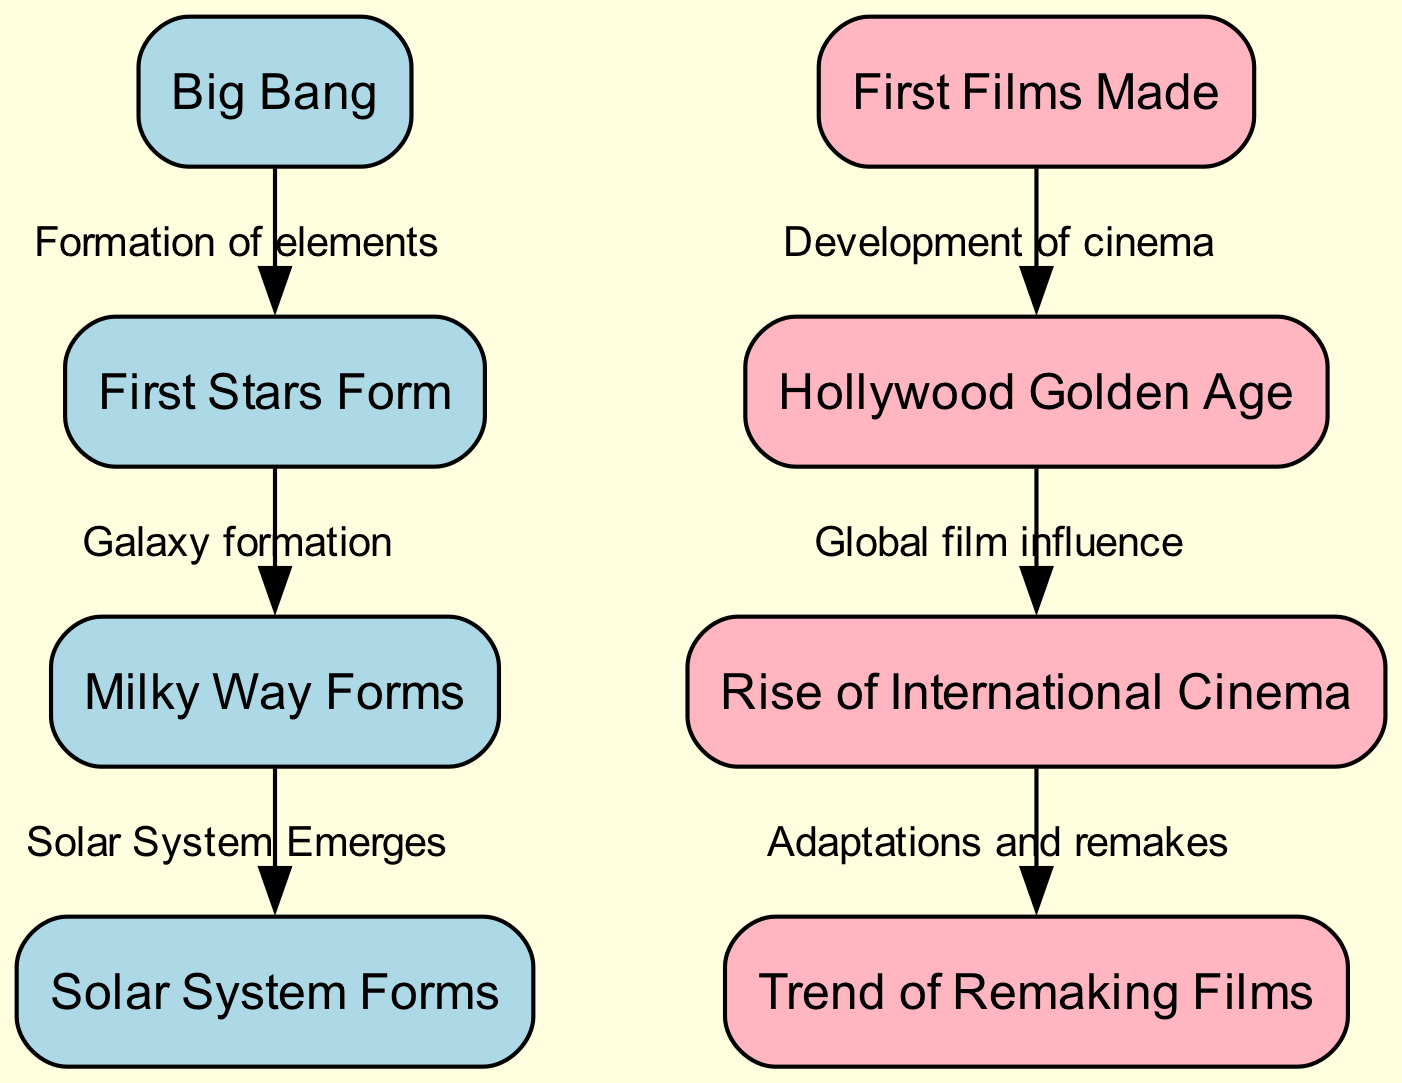What event follows the Big Bang in the diagram? The immediate event that follows the Big Bang, as indicated by the arrow leading from "Big Bang," is "First Stars Form." This is shown directly in the diagram as the first event after the initial occurrence of the Big Bang.
Answer: First Stars Form How many nodes are present in the film industry section? The film industry section includes four nodes: "First Films Made," "Hollywood Golden Age," "Rise of International Cinema," and "Trend of Remaking Films." By counting these boxes in that section of the diagram, we see that there are four nodes.
Answer: Four What is the relationship between "Milky Way Forms" and "Solar System Forms"? The relationship indicated in the diagram shows that "Milky Way Forms" directly leads to the next event, which is "Solar System Forms." This connection is represented by an arrow that specifies the sequence of events in the astronomy timeline.
Answer: Solar System Emerges Which event is associated with the "Rise of International Cinema"? The event that follows the "Rise of International Cinema" is the "Trend of Remaking Films." This connection in the diagram is shown by an arrow pointing from "Rise of International Cinema" to "Trend of Remaking Films."
Answer: Trend of Remaking Films What comes after the "Hollywood Golden Age"? Following the "Hollywood Golden Age," the next event in the film industry timeline depicted in the diagram is the "Rise of International Cinema." An arrow indicates this succession, clearly marking the progression from one phase to the next.
Answer: Rise of International Cinema What links "First Films Made" to "Hollywood Golden Age"? The link shown in the diagram is a direct relationship where "First Films Made" transitions to "Hollywood Golden Age," indicating the development of cinema as a continuation from the inception of the film industry. This is represented by an arrow.
Answer: Development of cinema How many edges connect the astronomy events? There are three edges that connect the astronomy events: from "Big Bang" to "First Stars Form," from "First Stars Form" to "Milky Way Forms," and from "Milky Way Forms" to "Solar System Forms." By counting these connections in the astronomy section of the diagram, we find that there are three edges.
Answer: Three What visual color represents the film industry events in the diagram? The film industry events are represented by light pink color boxes in the diagram. This color choice is consistent across all film industry nodes.
Answer: Light pink 